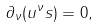Convert formula to latex. <formula><loc_0><loc_0><loc_500><loc_500>\partial _ { \nu } ( u ^ { \nu } s ) = 0 ,</formula> 